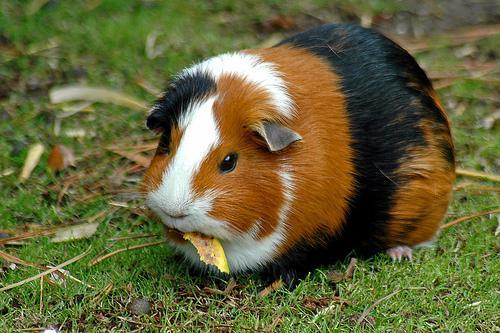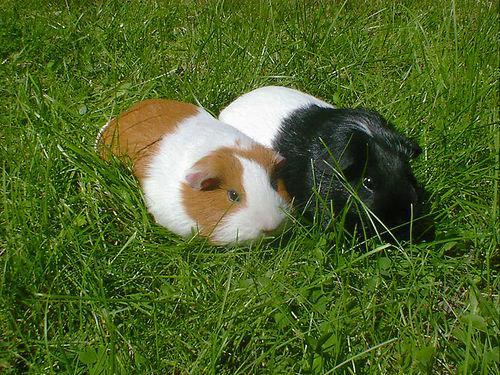The first image is the image on the left, the second image is the image on the right. For the images displayed, is the sentence "The right image contains exactly two rodents." factually correct? Answer yes or no. Yes. The first image is the image on the left, the second image is the image on the right. For the images displayed, is the sentence "All guinea pigs are on green grass, and none of them are standing upright." factually correct? Answer yes or no. Yes. 